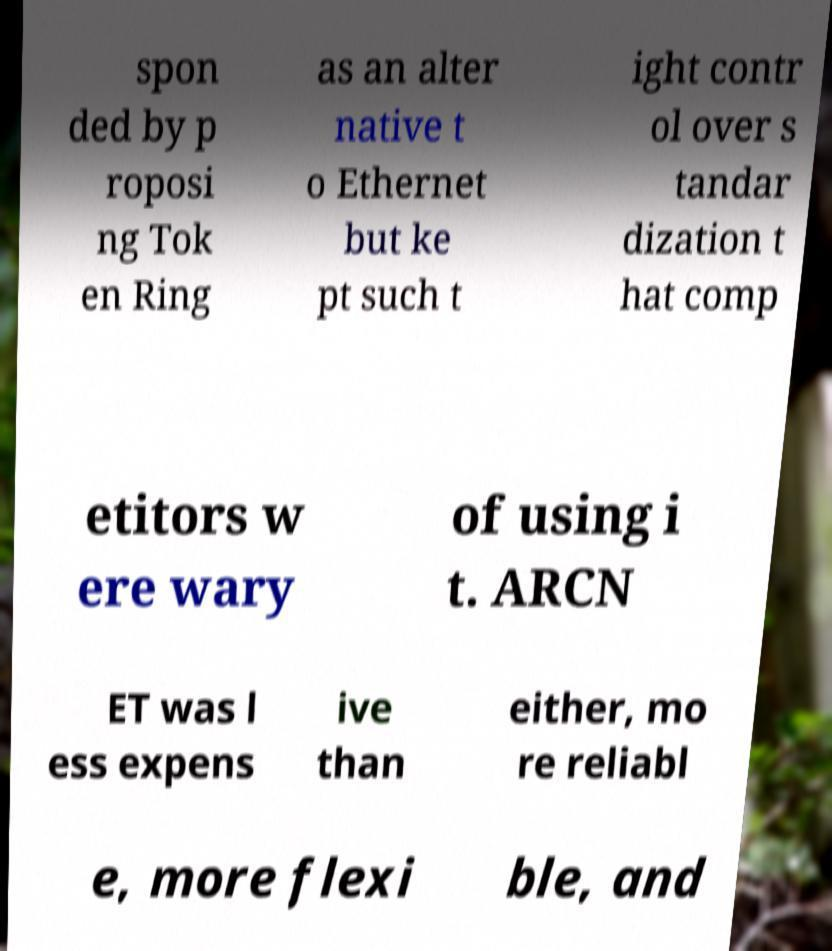What messages or text are displayed in this image? I need them in a readable, typed format. spon ded by p roposi ng Tok en Ring as an alter native t o Ethernet but ke pt such t ight contr ol over s tandar dization t hat comp etitors w ere wary of using i t. ARCN ET was l ess expens ive than either, mo re reliabl e, more flexi ble, and 